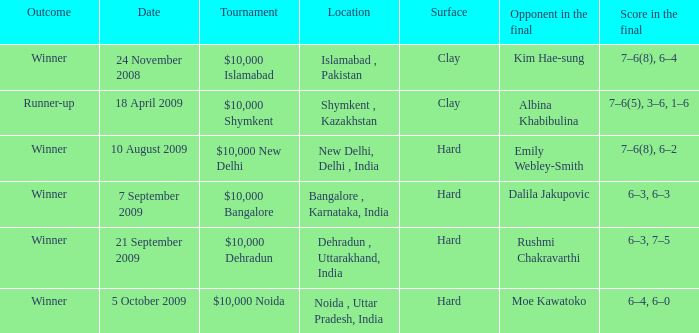Help me parse the entirety of this table. {'header': ['Outcome', 'Date', 'Tournament', 'Location', 'Surface', 'Opponent in the final', 'Score in the final'], 'rows': [['Winner', '24 November 2008', '$10,000 Islamabad', 'Islamabad , Pakistan', 'Clay', 'Kim Hae-sung', '7–6(8), 6–4'], ['Runner-up', '18 April 2009', '$10,000 Shymkent', 'Shymkent , Kazakhstan', 'Clay', 'Albina Khabibulina', '7–6(5), 3–6, 1–6'], ['Winner', '10 August 2009', '$10,000 New Delhi', 'New Delhi, Delhi , India', 'Hard', 'Emily Webley-Smith', '7–6(8), 6–2'], ['Winner', '7 September 2009', '$10,000 Bangalore', 'Bangalore , Karnataka, India', 'Hard', 'Dalila Jakupovic', '6–3, 6–3'], ['Winner', '21 September 2009', '$10,000 Dehradun', 'Dehradun , Uttarakhand, India', 'Hard', 'Rushmi Chakravarthi', '6–3, 7–5'], ['Winner', '5 October 2009', '$10,000 Noida', 'Noida , Uttar Pradesh, India', 'Hard', 'Moe Kawatoko', '6–4, 6–0']]} In how many dates the opponen in the final was rushmi chakravarthi 1.0. 